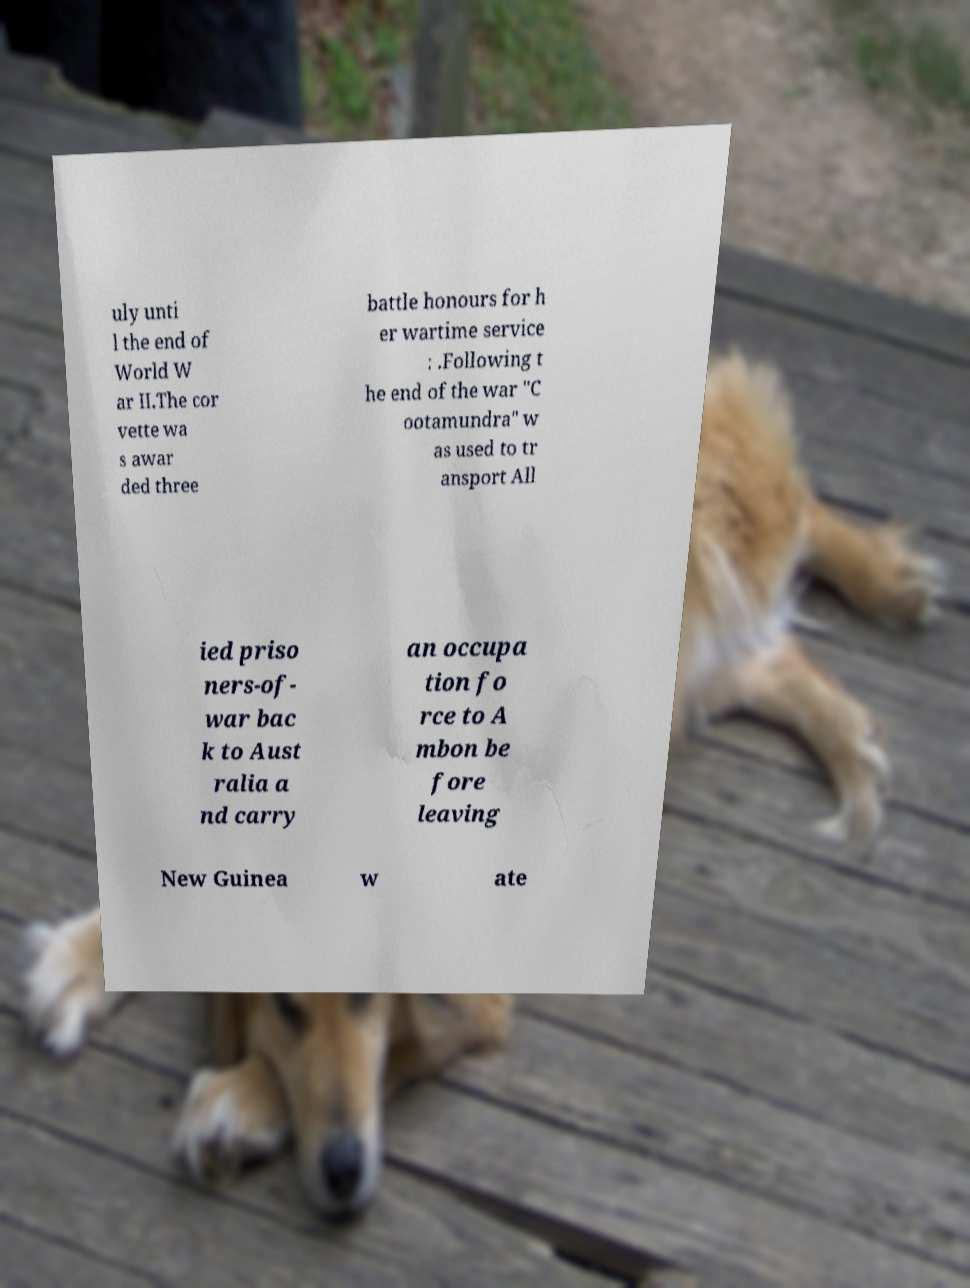I need the written content from this picture converted into text. Can you do that? uly unti l the end of World W ar II.The cor vette wa s awar ded three battle honours for h er wartime service : .Following t he end of the war "C ootamundra" w as used to tr ansport All ied priso ners-of- war bac k to Aust ralia a nd carry an occupa tion fo rce to A mbon be fore leaving New Guinea w ate 